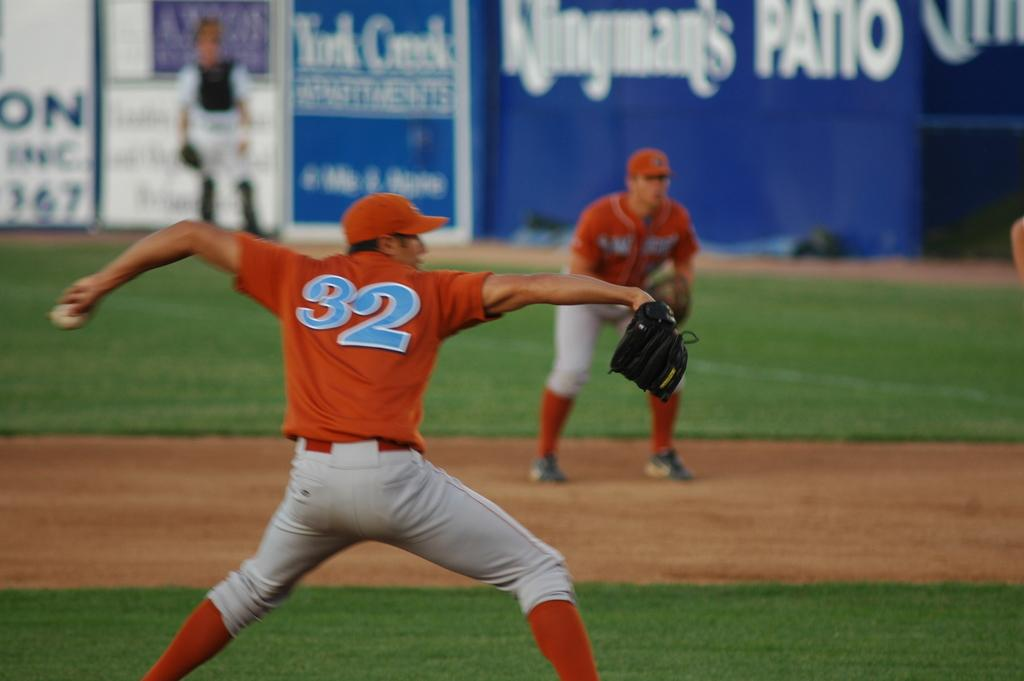<image>
Share a concise interpretation of the image provided. A sports man in a number 32 shirt throwing a ball. 